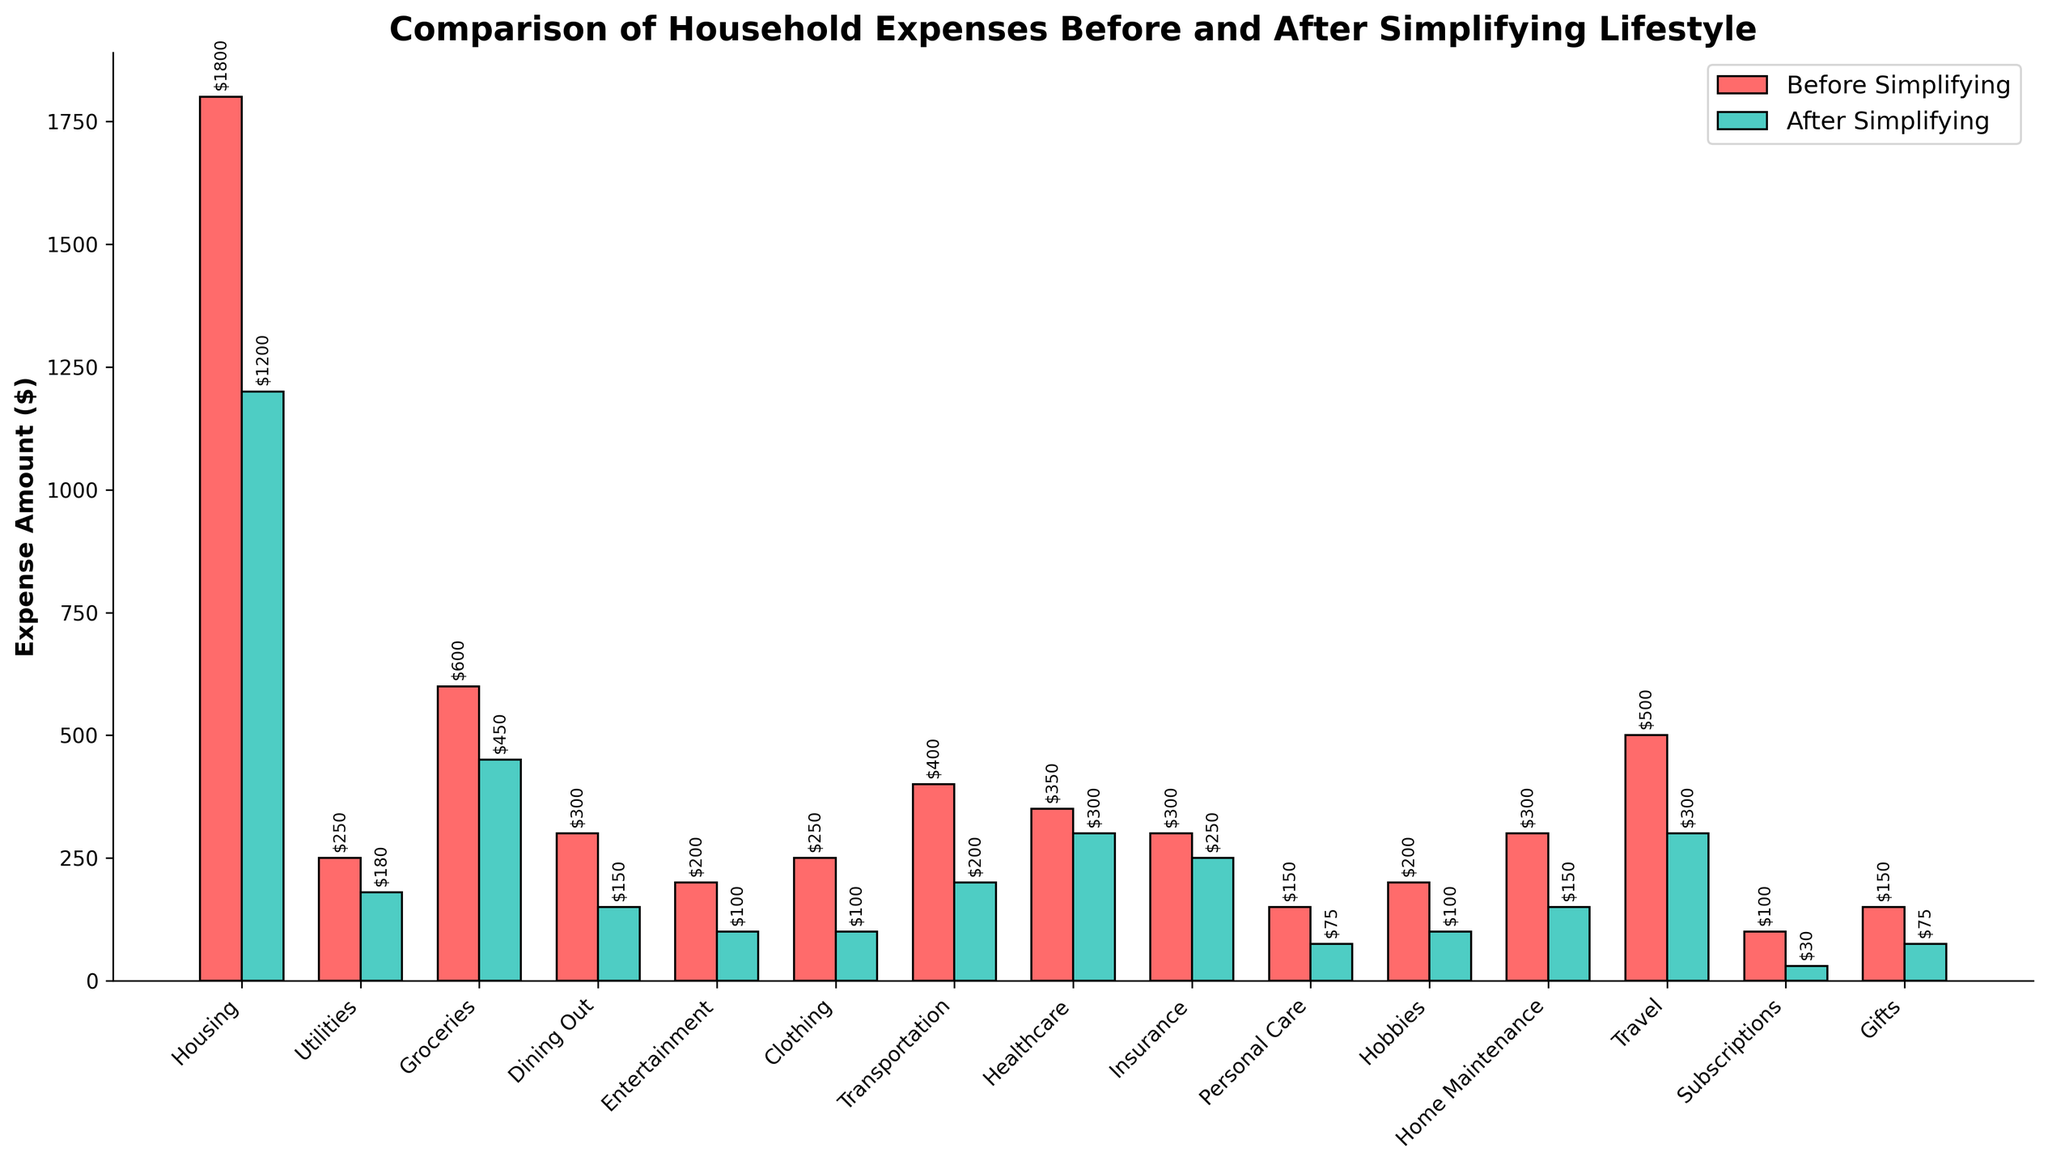Which category experienced the largest reduction in expenses after simplifying? To find the largest reduction, calculate the difference between the expenses before and after simplifying for each category and identify the highest value. The largest reduction is in Housing, decreasing from $1800 to $1200, a reduction of $600.
Answer: Housing Which expense category remained nearly the same? To determine which expense category remained nearly the same, compare the before and after values for each category. The Healthcare category experienced a small reduction from $350 to $300, which is a minor change compared to others.
Answer: Healthcare By how much did the Dining Out expenses decrease after simplifying and how does this compare to the decrease in Clothing expenses? To find the decrease, subtract the after value from the before value. The decrease in Dining Out is $300 - $150 = $150. For Clothing, it is $250 - $100 = $150. The decreases in both categories are equal.
Answer: $150, equal What is the total expense for Groceries and Utilities before simplifying, and how does it compare to the total for these categories after simplifying? Sum the expenses for Groceries and Utilities before simplifying ($600 + $250 = $850) and after simplifying ($450 + $180 = $630). The difference is $850 - $630 = $220 more before simplifying.
Answer: $850 (before), $630 (after), $220 more before Which category has the smallest expense after simplifying? Look for the category with the smallest bar in the "After Simplifying" section. Subscriptions have the smallest expense, reduced to $30.
Answer: Subscriptions Compare the height of the Hobby expenses before and after simplifying. Did both increase, decrease, or remain the same? Observe the height of the bars for Hobbies. Before simplifying, it was $200 and after simplifying, it decreased to $100. So, the expenses decreased.
Answer: Decrease What is the combined total spent on Travel and Entertainment after simplifying, and is it more or less than what was spent only on Healthcare before simplifying? Sum the expenses for Travel ($300) and Entertainment ($100) after simplifying ($300 + $100 = $400). Compare this to Healthcare before simplifying ($350). The combined total is more.
Answer: More, $400 vs $350 How much did Personal Care expenses decrease in percentage terms after simplifying? First, calculate the amount decreased: $150 - $75 = $75. The percentage decrease is ($75 / $150) * 100 = 50%.
Answer: 50% In which category is the visual difference in bar heights most noticeable between before and after simplifying? Look for the largest visual difference in bar heights. Housing has the most noticeable visual difference with a reduction from $1800 to $1200.
Answer: Housing 